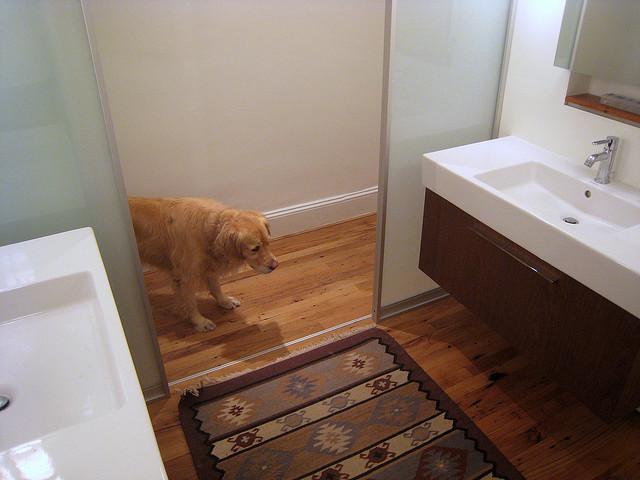How many sinks are there?
Give a very brief answer. 2. How many horses are going to pull this cart?
Give a very brief answer. 0. 